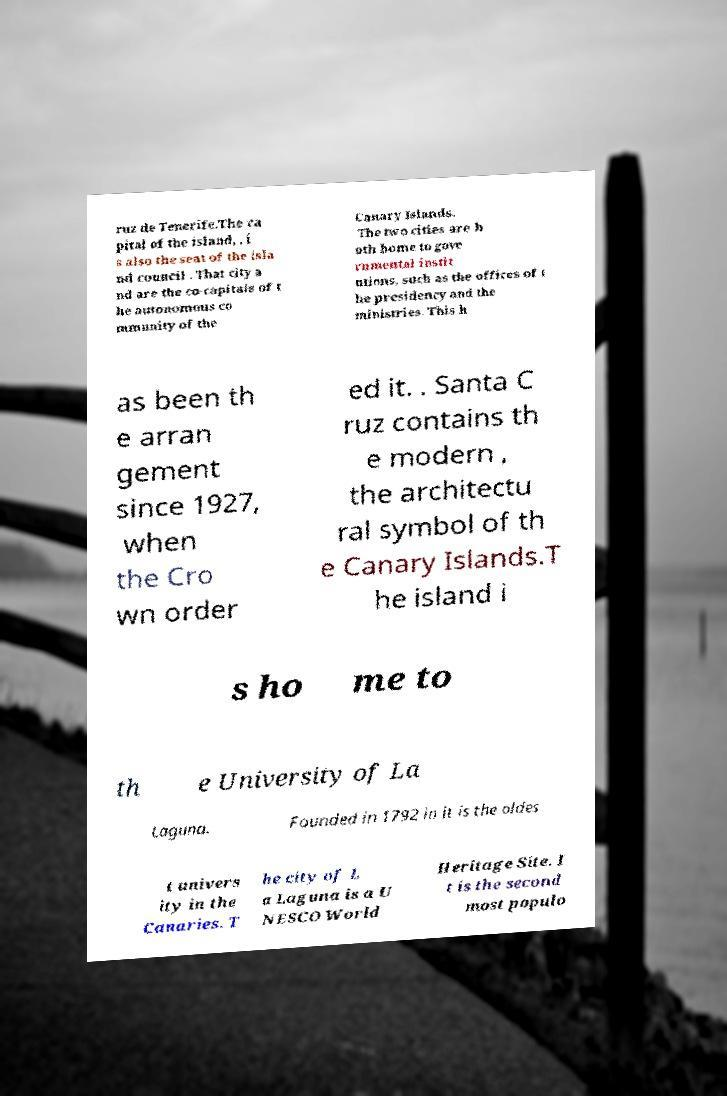Please identify and transcribe the text found in this image. ruz de Tenerife.The ca pital of the island, , i s also the seat of the isla nd council . That city a nd are the co-capitals of t he autonomous co mmunity of the Canary Islands. The two cities are b oth home to gove rnmental instit utions, such as the offices of t he presidency and the ministries. This h as been th e arran gement since 1927, when the Cro wn order ed it. . Santa C ruz contains th e modern , the architectu ral symbol of th e Canary Islands.T he island i s ho me to th e University of La Laguna. Founded in 1792 in it is the oldes t univers ity in the Canaries. T he city of L a Laguna is a U NESCO World Heritage Site. I t is the second most populo 